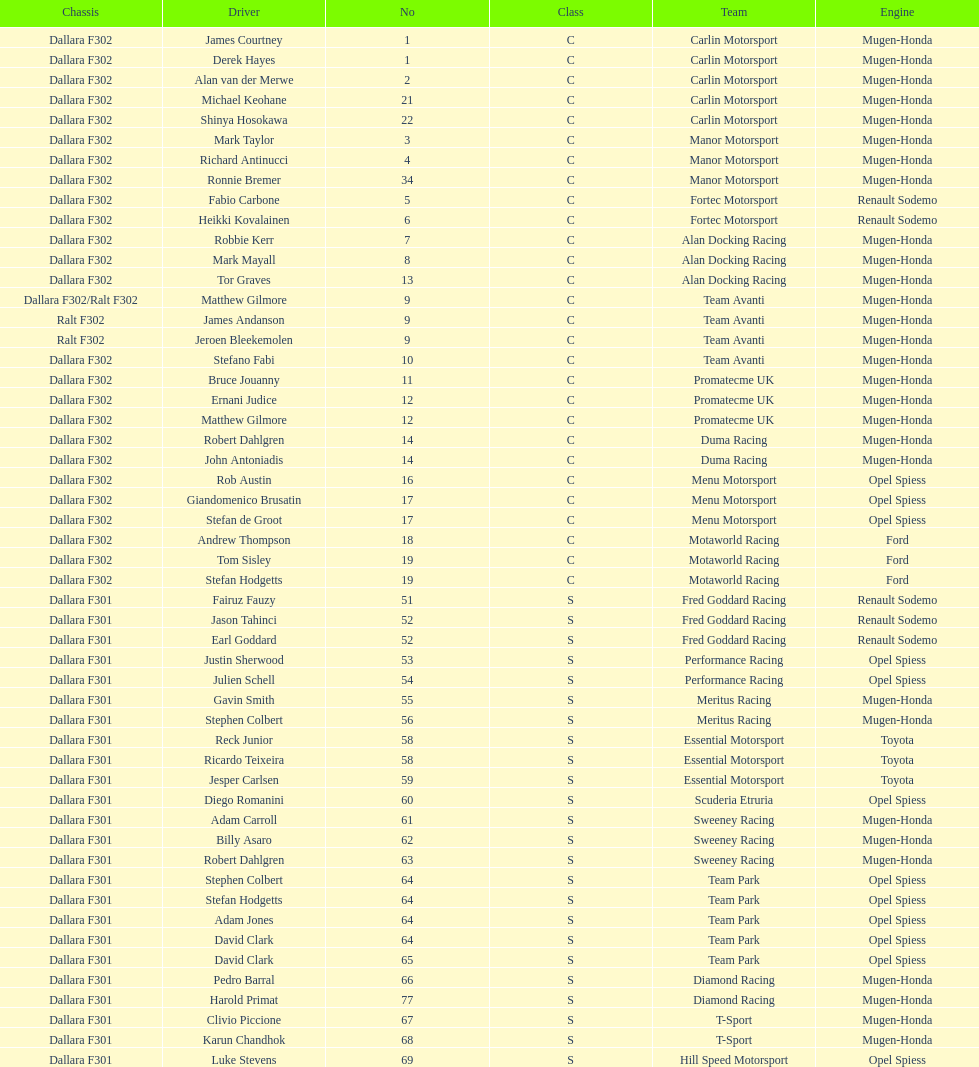Who had more drivers, team avanti or motaworld racing? Team Avanti. 